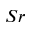Convert formula to latex. <formula><loc_0><loc_0><loc_500><loc_500>S r</formula> 